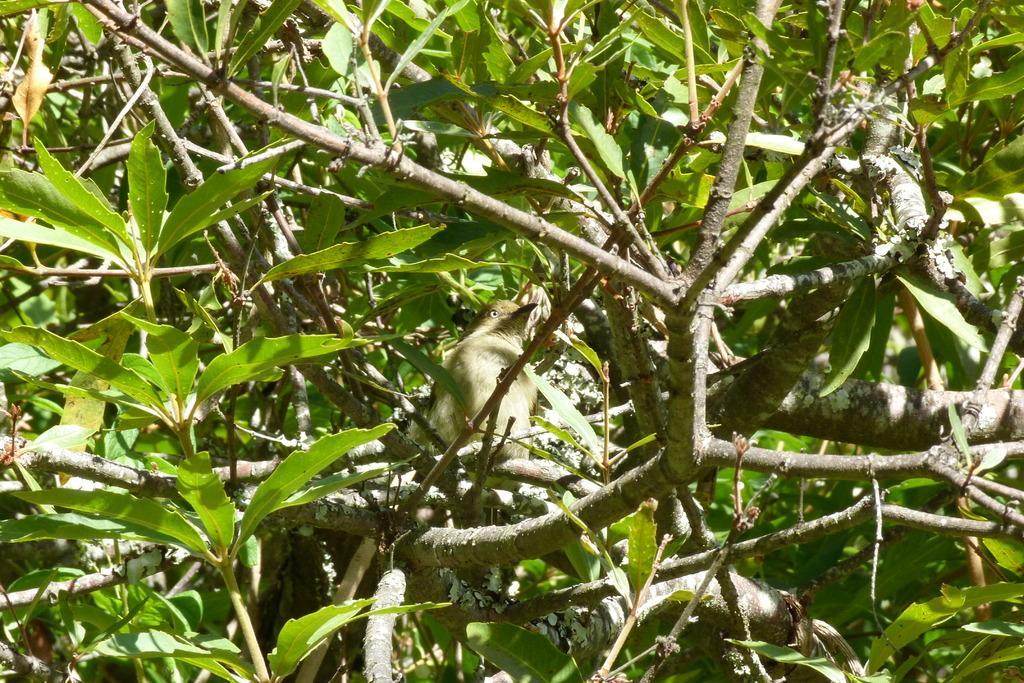In one or two sentences, can you explain what this image depicts? This is the picture of a tree. In this image there is a bird sitting on the branch of the tree. There are green color leaves on the tree. 